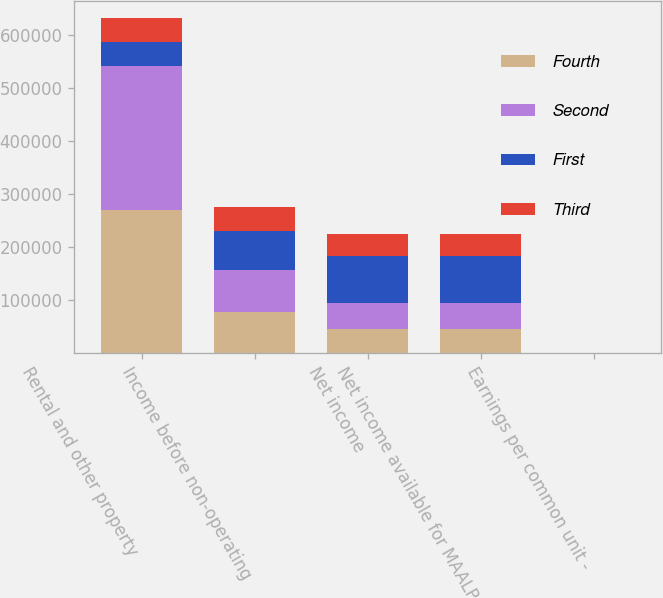<chart> <loc_0><loc_0><loc_500><loc_500><stacked_bar_chart><ecel><fcel>Rental and other property<fcel>Income before non-operating<fcel>Net income<fcel>Net income available for MAALP<fcel>Earnings per common unit -<nl><fcel>Fourth<fcel>269016<fcel>77422<fcel>45808<fcel>45808<fcel>0.61<nl><fcel>Second<fcel>272236<fcel>78215<fcel>47630<fcel>47630<fcel>0.6<nl><fcel>First<fcel>45213<fcel>74823<fcel>88906<fcel>88906<fcel>1.12<nl><fcel>Third<fcel>45213<fcel>44618<fcel>42058<fcel>41751<fcel>0.45<nl></chart> 